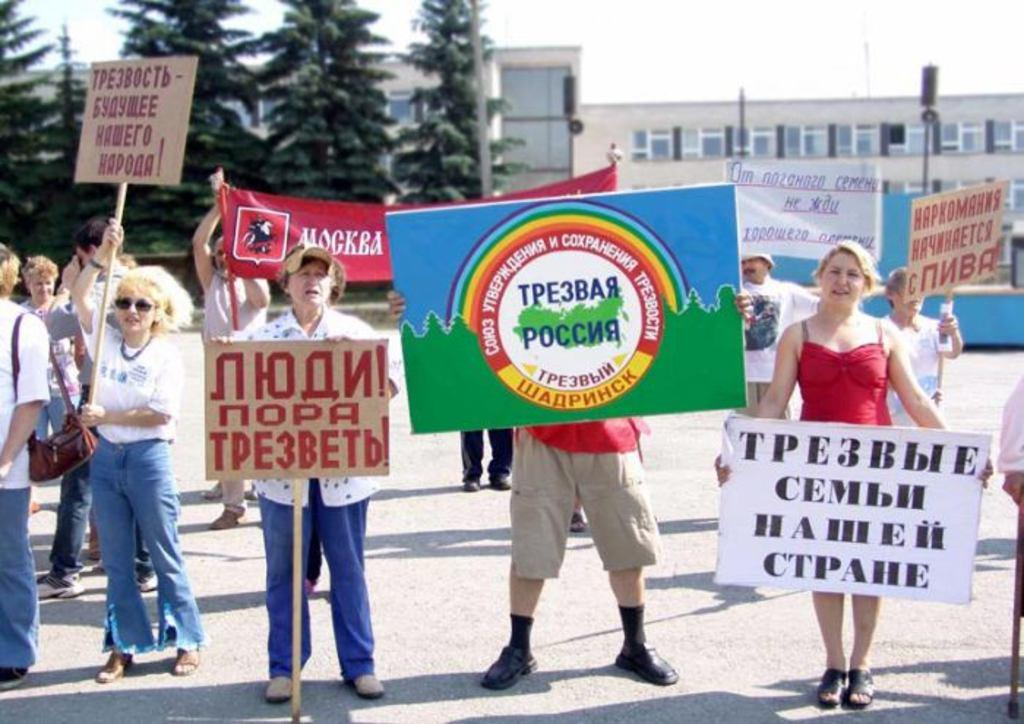What are the persons in the image doing? The persons in the image are standing on the road and holding boards with their hands. What can be seen in the background of the image? There are trees, poles, buildings, and the sky visible in the background of the image. What type of baseball equipment can be seen in the image? There is no baseball equipment present in the image. What type of polish is being applied to the persons in the image? There is no polish being applied to the persons in the image; they are simply holding boards with their hands. 